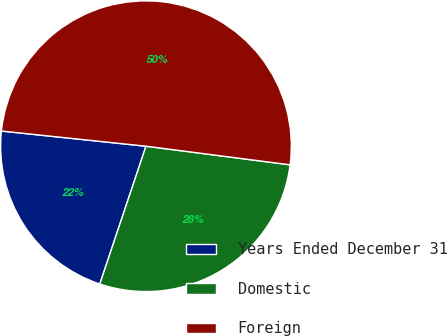Convert chart to OTSL. <chart><loc_0><loc_0><loc_500><loc_500><pie_chart><fcel>Years Ended December 31<fcel>Domestic<fcel>Foreign<nl><fcel>21.52%<fcel>28.1%<fcel>50.38%<nl></chart> 